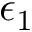<formula> <loc_0><loc_0><loc_500><loc_500>\epsilon _ { 1 }</formula> 